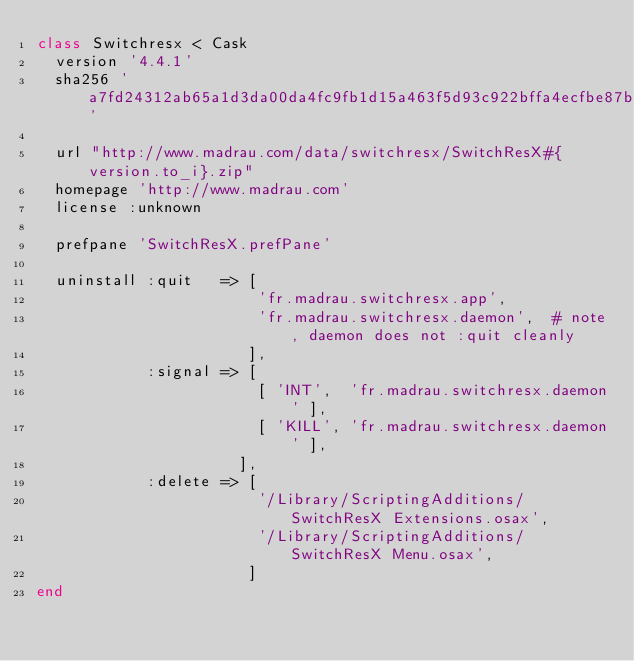Convert code to text. <code><loc_0><loc_0><loc_500><loc_500><_Ruby_>class Switchresx < Cask
  version '4.4.1'
  sha256 'a7fd24312ab65a1d3da00da4fc9fb1d15a463f5d93c922bffa4ecfbe87b8e3cf'

  url "http://www.madrau.com/data/switchresx/SwitchResX#{version.to_i}.zip"
  homepage 'http://www.madrau.com'
  license :unknown

  prefpane 'SwitchResX.prefPane'

  uninstall :quit   => [
                        'fr.madrau.switchresx.app',
                        'fr.madrau.switchresx.daemon',  # note, daemon does not :quit cleanly
                       ],
            :signal => [
                        [ 'INT',  'fr.madrau.switchresx.daemon' ],
                        [ 'KILL', 'fr.madrau.switchresx.daemon' ],
                      ],
            :delete => [
                        '/Library/ScriptingAdditions/SwitchResX Extensions.osax',
                        '/Library/ScriptingAdditions/SwitchResX Menu.osax',
                       ]
end
</code> 